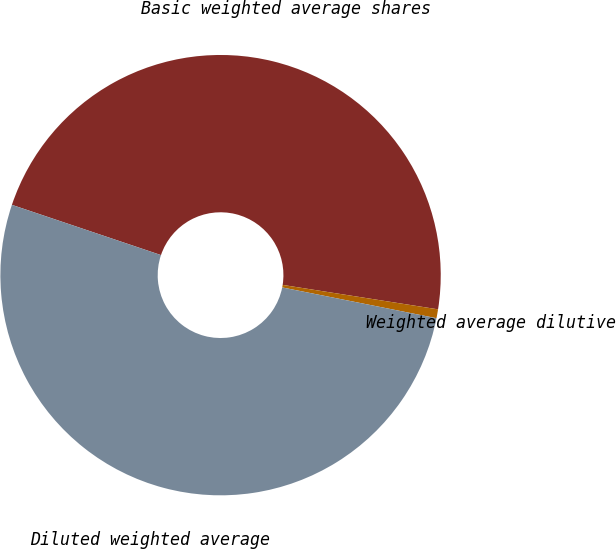Convert chart. <chart><loc_0><loc_0><loc_500><loc_500><pie_chart><fcel>Basic weighted average shares<fcel>Weighted average dilutive<fcel>Diluted weighted average<nl><fcel>47.31%<fcel>0.65%<fcel>52.04%<nl></chart> 